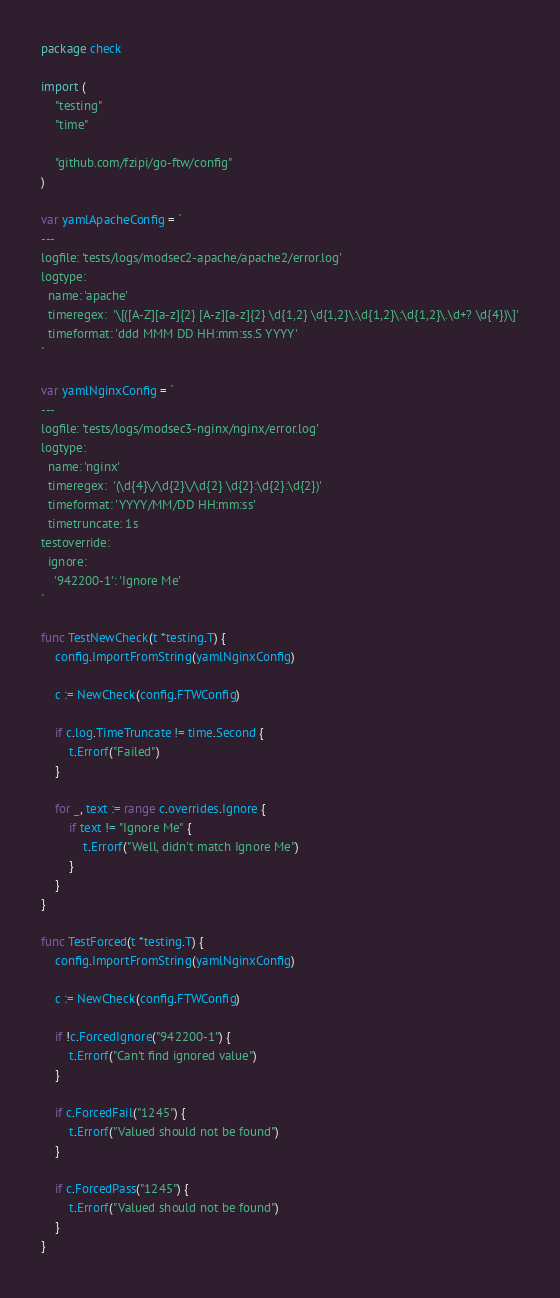<code> <loc_0><loc_0><loc_500><loc_500><_Go_>package check

import (
	"testing"
	"time"

	"github.com/fzipi/go-ftw/config"
)

var yamlApacheConfig = `
---
logfile: 'tests/logs/modsec2-apache/apache2/error.log'
logtype:
  name: 'apache'
  timeregex:  '\[([A-Z][a-z]{2} [A-z][a-z]{2} \d{1,2} \d{1,2}\:\d{1,2}\:\d{1,2}\.\d+? \d{4})\]'
  timeformat: 'ddd MMM DD HH:mm:ss.S YYYY'
`

var yamlNginxConfig = `
---
logfile: 'tests/logs/modsec3-nginx/nginx/error.log'
logtype:
  name: 'nginx'
  timeregex:  '(\d{4}\/\d{2}\/\d{2} \d{2}:\d{2}:\d{2})'
  timeformat: 'YYYY/MM/DD HH:mm:ss'
  timetruncate: 1s
testoverride:
  ignore:
    '942200-1': 'Ignore Me'
`

func TestNewCheck(t *testing.T) {
	config.ImportFromString(yamlNginxConfig)

	c := NewCheck(config.FTWConfig)

	if c.log.TimeTruncate != time.Second {
		t.Errorf("Failed")
	}

	for _, text := range c.overrides.Ignore {
		if text != "Ignore Me" {
			t.Errorf("Well, didn't match Ignore Me")
		}
	}
}

func TestForced(t *testing.T) {
	config.ImportFromString(yamlNginxConfig)

	c := NewCheck(config.FTWConfig)

	if !c.ForcedIgnore("942200-1") {
		t.Errorf("Can't find ignored value")
	}

	if c.ForcedFail("1245") {
		t.Errorf("Valued should not be found")
	}

	if c.ForcedPass("1245") {
		t.Errorf("Valued should not be found")
	}
}
</code> 